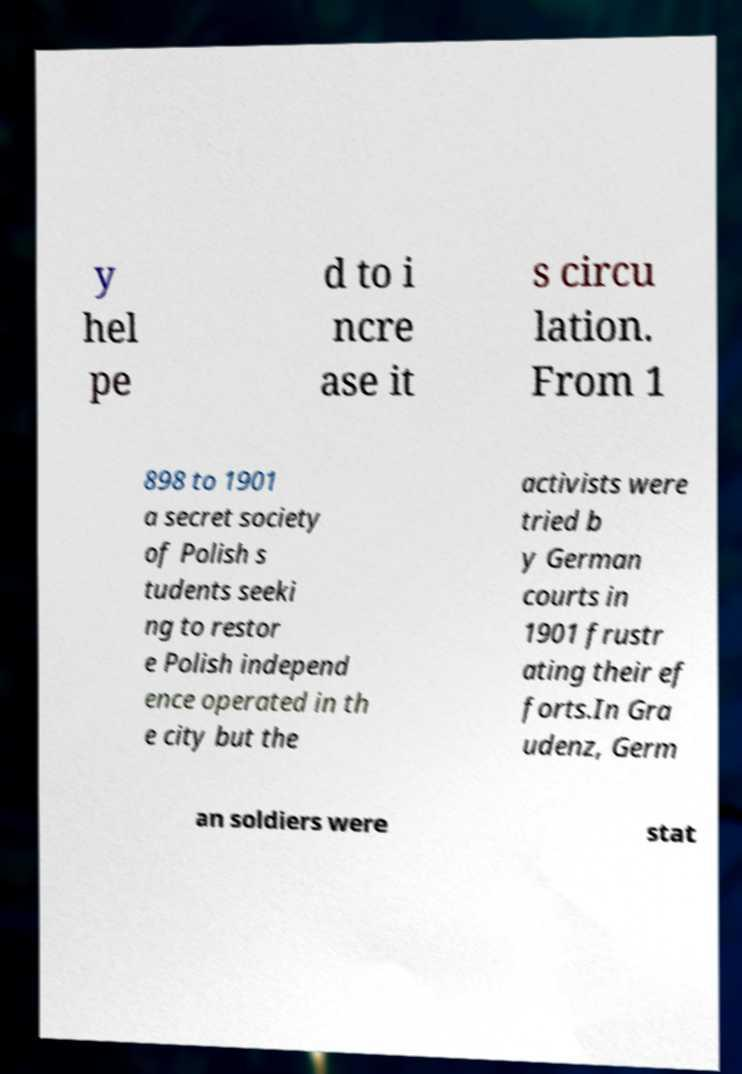Can you accurately transcribe the text from the provided image for me? y hel pe d to i ncre ase it s circu lation. From 1 898 to 1901 a secret society of Polish s tudents seeki ng to restor e Polish independ ence operated in th e city but the activists were tried b y German courts in 1901 frustr ating their ef forts.In Gra udenz, Germ an soldiers were stat 